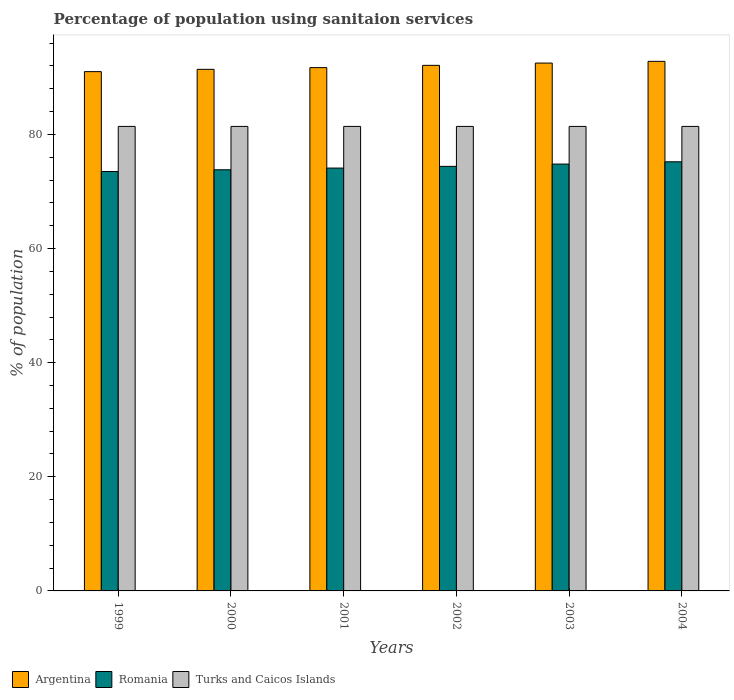How many different coloured bars are there?
Offer a very short reply. 3. How many groups of bars are there?
Provide a short and direct response. 6. How many bars are there on the 1st tick from the left?
Keep it short and to the point. 3. What is the label of the 1st group of bars from the left?
Provide a short and direct response. 1999. In how many cases, is the number of bars for a given year not equal to the number of legend labels?
Offer a terse response. 0. What is the percentage of population using sanitaion services in Argentina in 2000?
Offer a terse response. 91.4. Across all years, what is the maximum percentage of population using sanitaion services in Romania?
Make the answer very short. 75.2. Across all years, what is the minimum percentage of population using sanitaion services in Romania?
Your response must be concise. 73.5. In which year was the percentage of population using sanitaion services in Romania minimum?
Provide a succinct answer. 1999. What is the total percentage of population using sanitaion services in Argentina in the graph?
Your response must be concise. 551.5. What is the difference between the percentage of population using sanitaion services in Romania in 2001 and that in 2002?
Make the answer very short. -0.3. What is the difference between the percentage of population using sanitaion services in Romania in 2002 and the percentage of population using sanitaion services in Argentina in 2004?
Your response must be concise. -18.4. What is the average percentage of population using sanitaion services in Argentina per year?
Make the answer very short. 91.92. In the year 2000, what is the difference between the percentage of population using sanitaion services in Romania and percentage of population using sanitaion services in Argentina?
Provide a succinct answer. -17.6. In how many years, is the percentage of population using sanitaion services in Turks and Caicos Islands greater than 68 %?
Provide a short and direct response. 6. What is the ratio of the percentage of population using sanitaion services in Romania in 1999 to that in 2004?
Make the answer very short. 0.98. Is the difference between the percentage of population using sanitaion services in Romania in 2003 and 2004 greater than the difference between the percentage of population using sanitaion services in Argentina in 2003 and 2004?
Provide a short and direct response. No. What is the difference between the highest and the second highest percentage of population using sanitaion services in Romania?
Ensure brevity in your answer.  0.4. What is the difference between the highest and the lowest percentage of population using sanitaion services in Argentina?
Keep it short and to the point. 1.8. Is the sum of the percentage of population using sanitaion services in Argentina in 2001 and 2003 greater than the maximum percentage of population using sanitaion services in Romania across all years?
Ensure brevity in your answer.  Yes. What does the 2nd bar from the left in 2000 represents?
Your response must be concise. Romania. What does the 2nd bar from the right in 2000 represents?
Make the answer very short. Romania. How many bars are there?
Offer a terse response. 18. How many years are there in the graph?
Give a very brief answer. 6. Does the graph contain grids?
Your answer should be very brief. No. How many legend labels are there?
Give a very brief answer. 3. How are the legend labels stacked?
Give a very brief answer. Horizontal. What is the title of the graph?
Give a very brief answer. Percentage of population using sanitaion services. What is the label or title of the X-axis?
Offer a terse response. Years. What is the label or title of the Y-axis?
Your answer should be very brief. % of population. What is the % of population of Argentina in 1999?
Offer a very short reply. 91. What is the % of population in Romania in 1999?
Give a very brief answer. 73.5. What is the % of population in Turks and Caicos Islands in 1999?
Your response must be concise. 81.4. What is the % of population of Argentina in 2000?
Ensure brevity in your answer.  91.4. What is the % of population of Romania in 2000?
Make the answer very short. 73.8. What is the % of population of Turks and Caicos Islands in 2000?
Give a very brief answer. 81.4. What is the % of population in Argentina in 2001?
Your response must be concise. 91.7. What is the % of population in Romania in 2001?
Provide a short and direct response. 74.1. What is the % of population of Turks and Caicos Islands in 2001?
Provide a succinct answer. 81.4. What is the % of population of Argentina in 2002?
Your answer should be very brief. 92.1. What is the % of population of Romania in 2002?
Offer a terse response. 74.4. What is the % of population of Turks and Caicos Islands in 2002?
Offer a terse response. 81.4. What is the % of population in Argentina in 2003?
Provide a succinct answer. 92.5. What is the % of population of Romania in 2003?
Provide a succinct answer. 74.8. What is the % of population of Turks and Caicos Islands in 2003?
Provide a short and direct response. 81.4. What is the % of population of Argentina in 2004?
Your response must be concise. 92.8. What is the % of population of Romania in 2004?
Your response must be concise. 75.2. What is the % of population in Turks and Caicos Islands in 2004?
Your response must be concise. 81.4. Across all years, what is the maximum % of population of Argentina?
Your answer should be very brief. 92.8. Across all years, what is the maximum % of population of Romania?
Your answer should be very brief. 75.2. Across all years, what is the maximum % of population in Turks and Caicos Islands?
Ensure brevity in your answer.  81.4. Across all years, what is the minimum % of population of Argentina?
Your answer should be compact. 91. Across all years, what is the minimum % of population of Romania?
Ensure brevity in your answer.  73.5. Across all years, what is the minimum % of population of Turks and Caicos Islands?
Offer a terse response. 81.4. What is the total % of population of Argentina in the graph?
Your answer should be compact. 551.5. What is the total % of population in Romania in the graph?
Keep it short and to the point. 445.8. What is the total % of population in Turks and Caicos Islands in the graph?
Your answer should be very brief. 488.4. What is the difference between the % of population in Romania in 1999 and that in 2000?
Provide a succinct answer. -0.3. What is the difference between the % of population of Turks and Caicos Islands in 1999 and that in 2000?
Provide a succinct answer. 0. What is the difference between the % of population of Argentina in 1999 and that in 2001?
Keep it short and to the point. -0.7. What is the difference between the % of population of Turks and Caicos Islands in 1999 and that in 2001?
Offer a terse response. 0. What is the difference between the % of population of Argentina in 1999 and that in 2002?
Provide a short and direct response. -1.1. What is the difference between the % of population of Turks and Caicos Islands in 1999 and that in 2002?
Provide a succinct answer. 0. What is the difference between the % of population of Argentina in 1999 and that in 2003?
Your answer should be very brief. -1.5. What is the difference between the % of population of Romania in 1999 and that in 2003?
Your response must be concise. -1.3. What is the difference between the % of population of Argentina in 2000 and that in 2002?
Offer a terse response. -0.7. What is the difference between the % of population in Romania in 2000 and that in 2002?
Keep it short and to the point. -0.6. What is the difference between the % of population of Turks and Caicos Islands in 2000 and that in 2002?
Offer a terse response. 0. What is the difference between the % of population of Argentina in 2000 and that in 2004?
Give a very brief answer. -1.4. What is the difference between the % of population of Romania in 2000 and that in 2004?
Provide a short and direct response. -1.4. What is the difference between the % of population of Turks and Caicos Islands in 2000 and that in 2004?
Your answer should be very brief. 0. What is the difference between the % of population of Argentina in 2001 and that in 2002?
Provide a succinct answer. -0.4. What is the difference between the % of population in Romania in 2001 and that in 2002?
Keep it short and to the point. -0.3. What is the difference between the % of population in Argentina in 2001 and that in 2003?
Your response must be concise. -0.8. What is the difference between the % of population in Turks and Caicos Islands in 2001 and that in 2003?
Provide a short and direct response. 0. What is the difference between the % of population of Argentina in 2001 and that in 2004?
Give a very brief answer. -1.1. What is the difference between the % of population in Turks and Caicos Islands in 2001 and that in 2004?
Provide a succinct answer. 0. What is the difference between the % of population in Argentina in 2002 and that in 2003?
Give a very brief answer. -0.4. What is the difference between the % of population in Romania in 2002 and that in 2003?
Your answer should be very brief. -0.4. What is the difference between the % of population in Turks and Caicos Islands in 2002 and that in 2003?
Ensure brevity in your answer.  0. What is the difference between the % of population of Romania in 2002 and that in 2004?
Offer a very short reply. -0.8. What is the difference between the % of population in Turks and Caicos Islands in 2002 and that in 2004?
Your response must be concise. 0. What is the difference between the % of population in Argentina in 2003 and that in 2004?
Provide a short and direct response. -0.3. What is the difference between the % of population of Romania in 2003 and that in 2004?
Offer a terse response. -0.4. What is the difference between the % of population in Argentina in 1999 and the % of population in Romania in 2000?
Provide a succinct answer. 17.2. What is the difference between the % of population in Argentina in 1999 and the % of population in Turks and Caicos Islands in 2000?
Your answer should be very brief. 9.6. What is the difference between the % of population of Argentina in 1999 and the % of population of Romania in 2002?
Your response must be concise. 16.6. What is the difference between the % of population of Romania in 1999 and the % of population of Turks and Caicos Islands in 2002?
Offer a terse response. -7.9. What is the difference between the % of population in Argentina in 1999 and the % of population in Romania in 2003?
Keep it short and to the point. 16.2. What is the difference between the % of population of Argentina in 1999 and the % of population of Romania in 2004?
Make the answer very short. 15.8. What is the difference between the % of population in Romania in 1999 and the % of population in Turks and Caicos Islands in 2004?
Offer a very short reply. -7.9. What is the difference between the % of population of Argentina in 2000 and the % of population of Romania in 2002?
Make the answer very short. 17. What is the difference between the % of population in Argentina in 2000 and the % of population in Turks and Caicos Islands in 2002?
Your answer should be very brief. 10. What is the difference between the % of population in Romania in 2000 and the % of population in Turks and Caicos Islands in 2002?
Provide a short and direct response. -7.6. What is the difference between the % of population in Argentina in 2000 and the % of population in Romania in 2003?
Give a very brief answer. 16.6. What is the difference between the % of population in Argentina in 2000 and the % of population in Romania in 2004?
Your answer should be very brief. 16.2. What is the difference between the % of population in Argentina in 2001 and the % of population in Turks and Caicos Islands in 2002?
Provide a short and direct response. 10.3. What is the difference between the % of population of Argentina in 2001 and the % of population of Turks and Caicos Islands in 2003?
Make the answer very short. 10.3. What is the difference between the % of population in Romania in 2001 and the % of population in Turks and Caicos Islands in 2003?
Your response must be concise. -7.3. What is the difference between the % of population in Argentina in 2001 and the % of population in Romania in 2004?
Offer a very short reply. 16.5. What is the difference between the % of population of Argentina in 2002 and the % of population of Turks and Caicos Islands in 2003?
Provide a short and direct response. 10.7. What is the difference between the % of population in Argentina in 2002 and the % of population in Turks and Caicos Islands in 2004?
Your answer should be compact. 10.7. What is the difference between the % of population of Romania in 2002 and the % of population of Turks and Caicos Islands in 2004?
Offer a terse response. -7. What is the difference between the % of population of Argentina in 2003 and the % of population of Romania in 2004?
Offer a very short reply. 17.3. What is the average % of population of Argentina per year?
Provide a short and direct response. 91.92. What is the average % of population in Romania per year?
Keep it short and to the point. 74.3. What is the average % of population in Turks and Caicos Islands per year?
Provide a short and direct response. 81.4. In the year 1999, what is the difference between the % of population of Argentina and % of population of Romania?
Offer a very short reply. 17.5. In the year 1999, what is the difference between the % of population of Argentina and % of population of Turks and Caicos Islands?
Make the answer very short. 9.6. In the year 1999, what is the difference between the % of population in Romania and % of population in Turks and Caicos Islands?
Your answer should be very brief. -7.9. In the year 2000, what is the difference between the % of population in Argentina and % of population in Romania?
Offer a terse response. 17.6. In the year 2000, what is the difference between the % of population of Argentina and % of population of Turks and Caicos Islands?
Ensure brevity in your answer.  10. In the year 2001, what is the difference between the % of population of Argentina and % of population of Romania?
Your answer should be compact. 17.6. In the year 2002, what is the difference between the % of population of Argentina and % of population of Romania?
Provide a succinct answer. 17.7. In the year 2003, what is the difference between the % of population in Argentina and % of population in Romania?
Provide a short and direct response. 17.7. In the year 2003, what is the difference between the % of population in Argentina and % of population in Turks and Caicos Islands?
Your answer should be very brief. 11.1. In the year 2004, what is the difference between the % of population in Argentina and % of population in Turks and Caicos Islands?
Offer a very short reply. 11.4. In the year 2004, what is the difference between the % of population of Romania and % of population of Turks and Caicos Islands?
Make the answer very short. -6.2. What is the ratio of the % of population in Romania in 1999 to that in 2000?
Ensure brevity in your answer.  1. What is the ratio of the % of population in Turks and Caicos Islands in 1999 to that in 2000?
Give a very brief answer. 1. What is the ratio of the % of population of Argentina in 1999 to that in 2001?
Offer a very short reply. 0.99. What is the ratio of the % of population in Turks and Caicos Islands in 1999 to that in 2001?
Ensure brevity in your answer.  1. What is the ratio of the % of population of Argentina in 1999 to that in 2002?
Your answer should be compact. 0.99. What is the ratio of the % of population in Romania in 1999 to that in 2002?
Offer a terse response. 0.99. What is the ratio of the % of population of Argentina in 1999 to that in 2003?
Your answer should be compact. 0.98. What is the ratio of the % of population of Romania in 1999 to that in 2003?
Provide a succinct answer. 0.98. What is the ratio of the % of population in Argentina in 1999 to that in 2004?
Make the answer very short. 0.98. What is the ratio of the % of population of Romania in 1999 to that in 2004?
Offer a very short reply. 0.98. What is the ratio of the % of population in Turks and Caicos Islands in 1999 to that in 2004?
Offer a terse response. 1. What is the ratio of the % of population of Argentina in 2000 to that in 2001?
Keep it short and to the point. 1. What is the ratio of the % of population of Turks and Caicos Islands in 2000 to that in 2001?
Your response must be concise. 1. What is the ratio of the % of population in Romania in 2000 to that in 2003?
Offer a very short reply. 0.99. What is the ratio of the % of population of Turks and Caicos Islands in 2000 to that in 2003?
Your response must be concise. 1. What is the ratio of the % of population in Argentina in 2000 to that in 2004?
Your response must be concise. 0.98. What is the ratio of the % of population in Romania in 2000 to that in 2004?
Your answer should be very brief. 0.98. What is the ratio of the % of population in Turks and Caicos Islands in 2000 to that in 2004?
Provide a succinct answer. 1. What is the ratio of the % of population in Romania in 2001 to that in 2002?
Ensure brevity in your answer.  1. What is the ratio of the % of population in Turks and Caicos Islands in 2001 to that in 2002?
Offer a terse response. 1. What is the ratio of the % of population in Argentina in 2001 to that in 2003?
Make the answer very short. 0.99. What is the ratio of the % of population in Romania in 2001 to that in 2003?
Provide a short and direct response. 0.99. What is the ratio of the % of population in Argentina in 2001 to that in 2004?
Your answer should be very brief. 0.99. What is the ratio of the % of population in Romania in 2001 to that in 2004?
Offer a very short reply. 0.99. What is the ratio of the % of population in Turks and Caicos Islands in 2002 to that in 2003?
Keep it short and to the point. 1. What is the ratio of the % of population in Argentina in 2002 to that in 2004?
Ensure brevity in your answer.  0.99. What is the ratio of the % of population of Romania in 2002 to that in 2004?
Your response must be concise. 0.99. What is the ratio of the % of population in Argentina in 2003 to that in 2004?
Provide a short and direct response. 1. What is the ratio of the % of population of Turks and Caicos Islands in 2003 to that in 2004?
Offer a very short reply. 1. What is the difference between the highest and the second highest % of population of Argentina?
Provide a short and direct response. 0.3. What is the difference between the highest and the second highest % of population in Turks and Caicos Islands?
Your response must be concise. 0. What is the difference between the highest and the lowest % of population in Romania?
Make the answer very short. 1.7. 